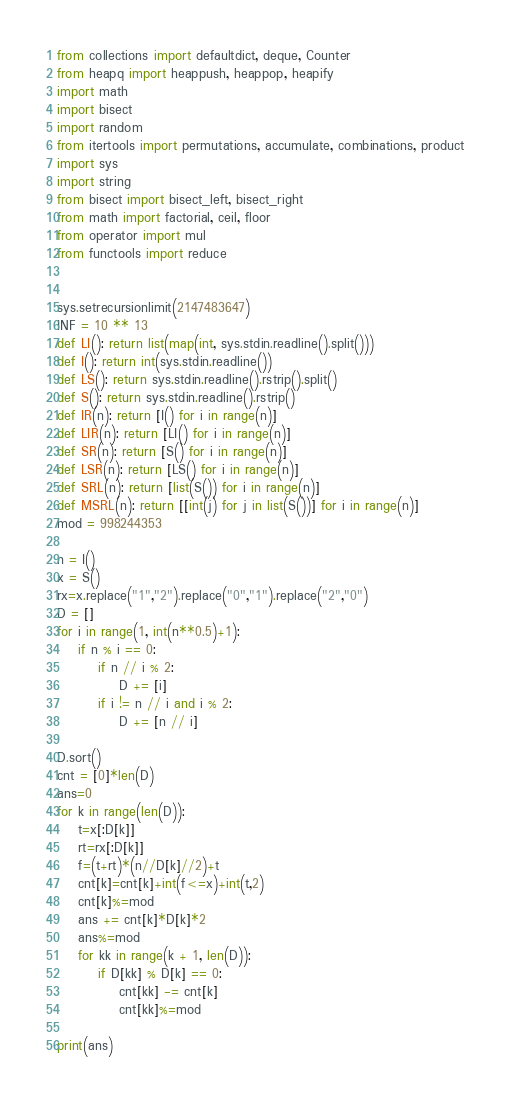Convert code to text. <code><loc_0><loc_0><loc_500><loc_500><_Python_>from collections import defaultdict, deque, Counter
from heapq import heappush, heappop, heapify
import math
import bisect
import random
from itertools import permutations, accumulate, combinations, product
import sys
import string
from bisect import bisect_left, bisect_right
from math import factorial, ceil, floor
from operator import mul
from functools import reduce


sys.setrecursionlimit(2147483647)
INF = 10 ** 13
def LI(): return list(map(int, sys.stdin.readline().split()))
def I(): return int(sys.stdin.readline())
def LS(): return sys.stdin.readline().rstrip().split()
def S(): return sys.stdin.readline().rstrip()
def IR(n): return [I() for i in range(n)]
def LIR(n): return [LI() for i in range(n)]
def SR(n): return [S() for i in range(n)]
def LSR(n): return [LS() for i in range(n)]
def SRL(n): return [list(S()) for i in range(n)]
def MSRL(n): return [[int(j) for j in list(S())] for i in range(n)]
mod = 998244353

n = I()
x = S()
rx=x.replace("1","2").replace("0","1").replace("2","0")
D = []
for i in range(1, int(n**0.5)+1):
    if n % i == 0:
        if n // i % 2:
            D += [i]
        if i != n // i and i % 2:
            D += [n // i]

D.sort()
cnt = [0]*len(D)
ans=0
for k in range(len(D)):
    t=x[:D[k]]
    rt=rx[:D[k]]
    f=(t+rt)*(n//D[k]//2)+t
    cnt[k]=cnt[k]+int(f<=x)+int(t,2)
    cnt[k]%=mod
    ans += cnt[k]*D[k]*2
    ans%=mod
    for kk in range(k + 1, len(D)):
        if D[kk] % D[k] == 0:
            cnt[kk] -= cnt[k]
            cnt[kk]%=mod

print(ans)
</code> 